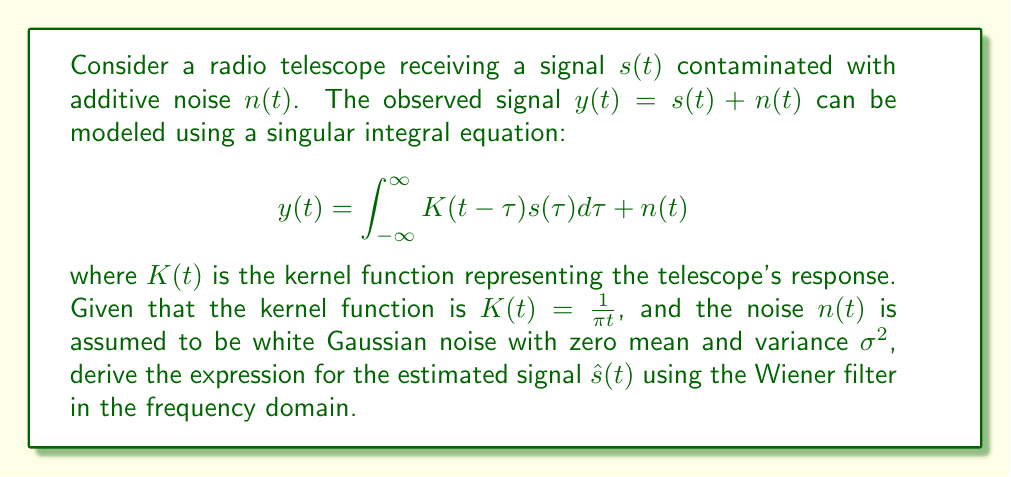Show me your answer to this math problem. To solve this problem, we'll follow these steps:

1) First, we need to convert the integral equation to the frequency domain using the Fourier transform:

   $$Y(\omega) = K(\omega)S(\omega) + N(\omega)$$

   where $Y(\omega)$, $K(\omega)$, $S(\omega)$, and $N(\omega)$ are the Fourier transforms of $y(t)$, $K(t)$, $s(t)$, and $n(t)$ respectively.

2) The Fourier transform of the kernel $K(t) = \frac{1}{\pi t}$ is:

   $$K(\omega) = \text{sgn}(\omega)$$

   where $\text{sgn}(\omega)$ is the sign function.

3) The Wiener filter in the frequency domain is given by:

   $$H(\omega) = \frac{K^*(\omega)}{|K(\omega)|^2 + \frac{S_n(\omega)}{S_s(\omega)}}$$

   where $K^*(\omega)$ is the complex conjugate of $K(\omega)$, $S_n(\omega)$ is the power spectral density of the noise, and $S_s(\omega)$ is the power spectral density of the signal.

4) For white Gaussian noise, $S_n(\omega) = \sigma^2$ (constant for all frequencies).

5) Substituting $K(\omega) = \text{sgn}(\omega)$ into the Wiener filter equation:

   $$H(\omega) = \frac{\text{sgn}(\omega)}{|\text{sgn}(\omega)|^2 + \frac{\sigma^2}{S_s(\omega)}}$$

6) Simplify, noting that $|\text{sgn}(\omega)|^2 = 1$:

   $$H(\omega) = \frac{\text{sgn}(\omega)}{1 + \frac{\sigma^2}{S_s(\omega)}}$$

7) The estimated signal in the frequency domain is:

   $$\hat{S}(\omega) = H(\omega)Y(\omega) = \frac{\text{sgn}(\omega)}{1 + \frac{\sigma^2}{S_s(\omega)}}Y(\omega)$$

8) To get $\hat{s}(t)$, we need to take the inverse Fourier transform of $\hat{S}(\omega)$:

   $$\hat{s}(t) = \mathcal{F}^{-1}\{\hat{S}(\omega)\} = \mathcal{F}^{-1}\left\{\frac{\text{sgn}(\omega)}{1 + \frac{\sigma^2}{S_s(\omega)}}Y(\omega)\right\}$$
Answer: $$\hat{s}(t) = \mathcal{F}^{-1}\left\{\frac{\text{sgn}(\omega)}{1 + \frac{\sigma^2}{S_s(\omega)}}Y(\omega)\right\}$$ 